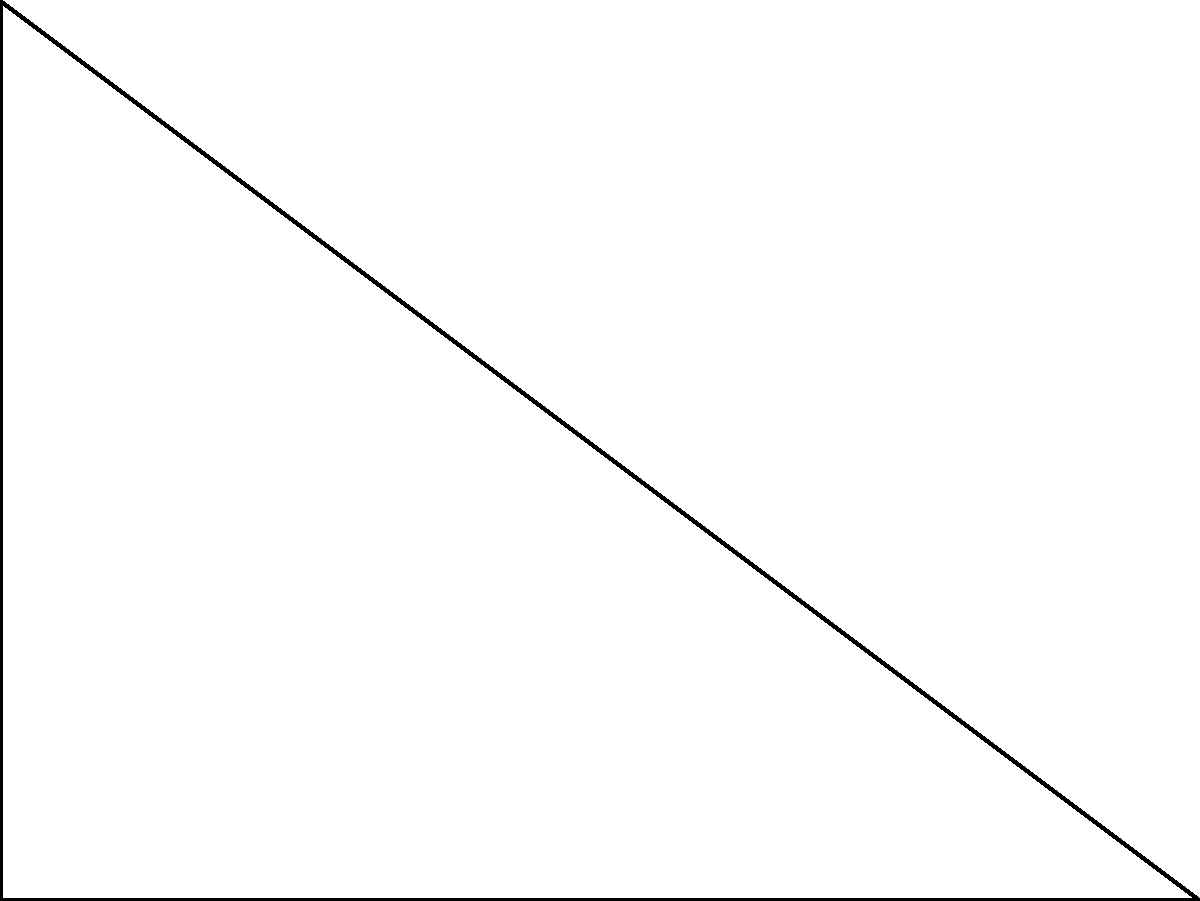For a nostalgic 80s-themed set design, you're creating a triangular backdrop. Two sides of the backdrop measure 8 feet and 10 feet, forming a right angle. What is the length of the third side? Let's approach this step-by-step using the Pythagorean theorem:

1) The Pythagorean theorem states that in a right triangle, $a^2 + b^2 = c^2$, where $c$ is the length of the hypotenuse (the side opposite the right angle), and $a$ and $b$ are the lengths of the other two sides.

2) In our triangle:
   - One side (let's call it $a$) is 8 feet
   - Another side (let's call it $b$) is 6 feet (this is the unknown side)
   - The hypotenuse (let's call it $c$) is 10 feet

3) Let's plug these into the Pythagorean theorem:
   $a^2 + b^2 = c^2$
   $8^2 + b^2 = 10^2$

4) Simplify:
   $64 + b^2 = 100$

5) Subtract 64 from both sides:
   $b^2 = 36$

6) Take the square root of both sides:
   $b = 6$

Therefore, the length of the unknown side is 6 feet.
Answer: 6 feet 